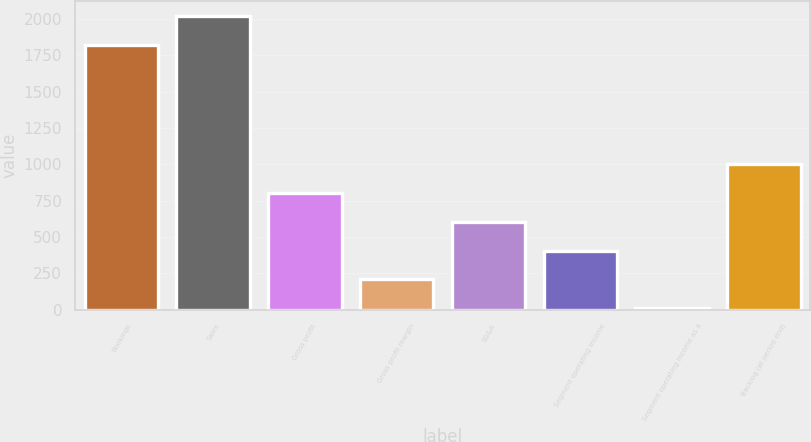<chart> <loc_0><loc_0><loc_500><loc_500><bar_chart><fcel>Bookings<fcel>Sales<fcel>Gross profit<fcel>Gross profit margin<fcel>SG&A<fcel>Segment operating income<fcel>Segment operating income as a<fcel>Backlog (at period end)<nl><fcel>1823.8<fcel>2022.54<fcel>803.56<fcel>207.34<fcel>604.82<fcel>406.08<fcel>8.6<fcel>1002.3<nl></chart> 